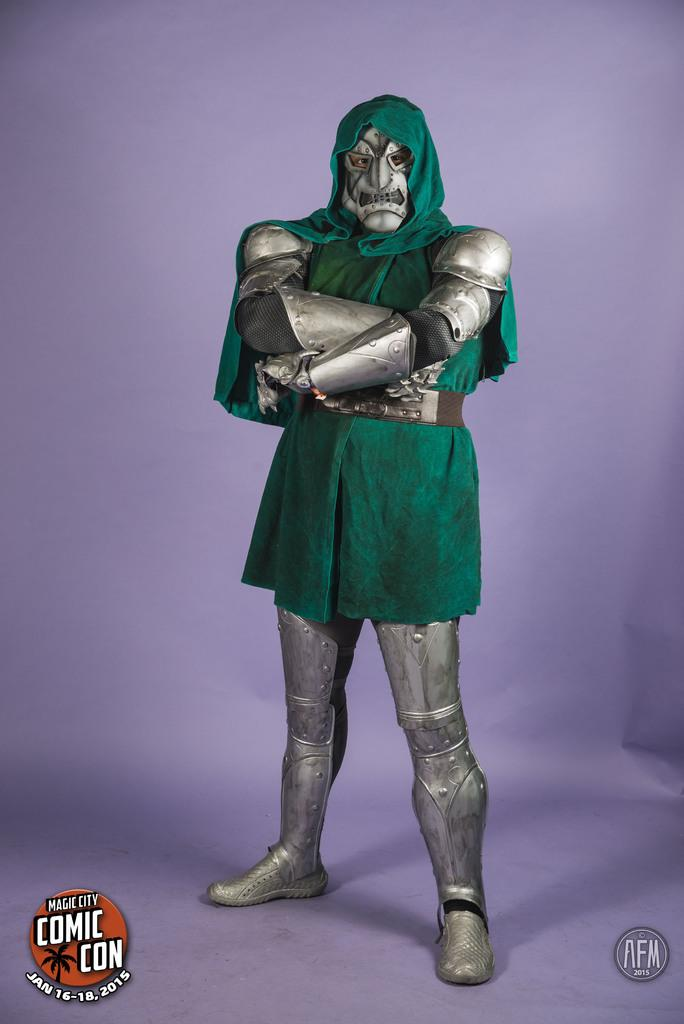Who is present in the image? There is a man in the image. What is the man wearing? The man is wearing armour and green cloth. Can you describe the background of the image? There is a purple color wall in the background of the image. Is there any additional information about the image itself? Yes, there is a watermark in the bottom left corner of the image. How many times has the image been copied and pasted? The number of times the image has been copied and pasted is not mentioned in the provided facts, and therefore cannot be determined. 